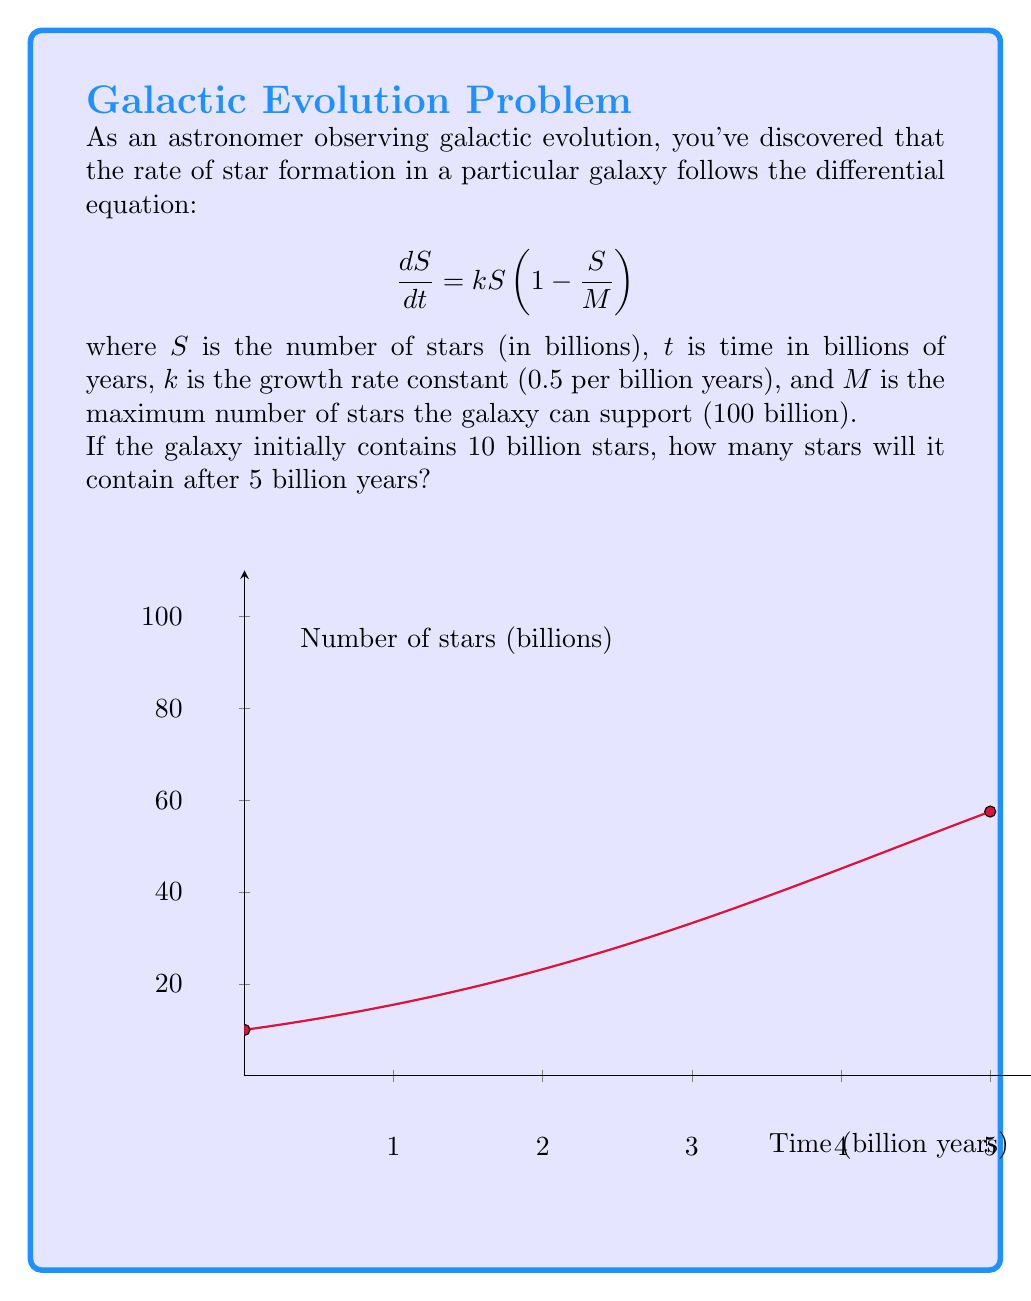Show me your answer to this math problem. To solve this problem, we need to follow these steps:

1) First, we recognize this as a logistic differential equation with the general form:
   $$\frac{dS}{dt} = kS(1 - \frac{S}{M})$$

2) The solution to this equation is:
   $$S(t) = \frac{M}{1 + (\frac{M}{S_0} - 1)e^{-kt}}$$
   where $S_0$ is the initial number of stars.

3) We're given:
   $k = 0.5$ per billion years
   $M = 100$ billion stars
   $S_0 = 10$ billion stars
   $t = 5$ billion years

4) Let's substitute these values into our solution:
   $$S(5) = \frac{100}{1 + (\frac{100}{10} - 1)e^{-0.5(5)}}$$

5) Simplify:
   $$S(5) = \frac{100}{1 + 9e^{-2.5}}$$

6) Calculate:
   $$S(5) \approx 71.65$$

Therefore, after 5 billion years, the galaxy will contain approximately 71.65 billion stars.
Answer: 71.65 billion stars 